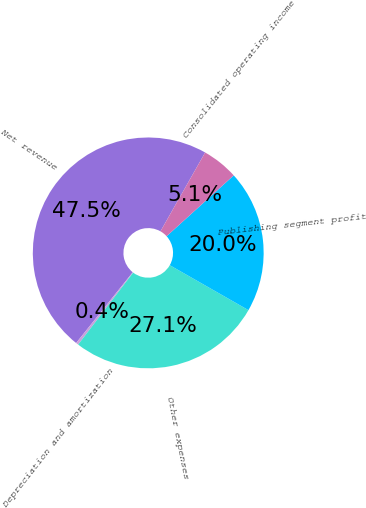Convert chart. <chart><loc_0><loc_0><loc_500><loc_500><pie_chart><fcel>Net revenue<fcel>Depreciation and amortization<fcel>Other expenses<fcel>Publishing segment profit<fcel>Consolidated operating income<nl><fcel>47.47%<fcel>0.35%<fcel>27.13%<fcel>19.98%<fcel>5.07%<nl></chart> 